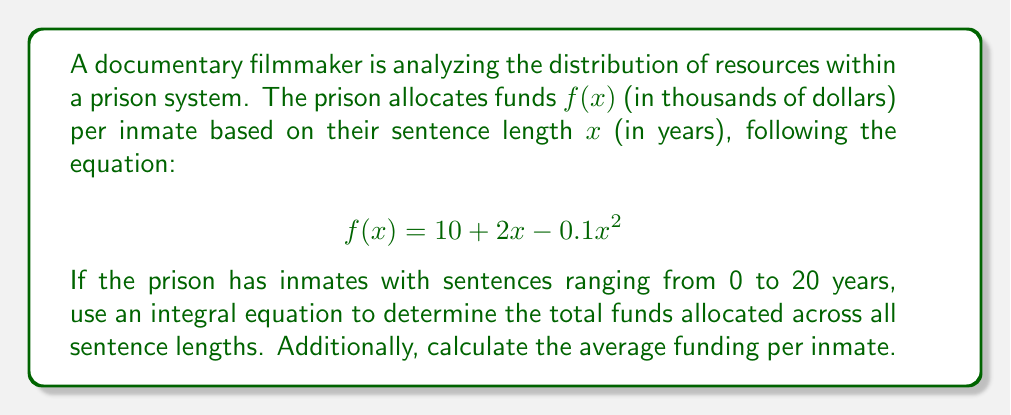Give your solution to this math problem. To solve this problem, we need to follow these steps:

1) The total funds allocated can be found by integrating the function $f(x)$ over the range of sentence lengths (0 to 20 years):

   $$\text{Total Funds} = \int_0^{20} f(x) dx = \int_0^{20} (10 + 2x - 0.1x^2) dx$$

2) Let's solve this integral:

   $$\begin{align}
   \int_0^{20} (10 + 2x - 0.1x^2) dx &= [10x + x^2 - \frac{0.1x^3}{3}]_0^{20} \\
   &= (200 + 400 - \frac{0.1 \cdot 8000}{3}) - (0 + 0 - 0) \\
   &= 600 - \frac{800}{3} \\
   &= 600 - 266.67 \\
   &= 333.33
   \end{align}$$

3) The result, 333.33, represents thousands of dollars. So the total funds allocated are $333,330.

4) To find the average funding per inmate, we need to divide the total funds by the number of years (which represents the number of different sentence lengths):

   $$\text{Average Funding} = \frac{333.33}{20} = 16.67$$

5) This means the average funding per inmate is $16,670.
Answer: Total funds: $333,330; Average funding per inmate: $16,670 